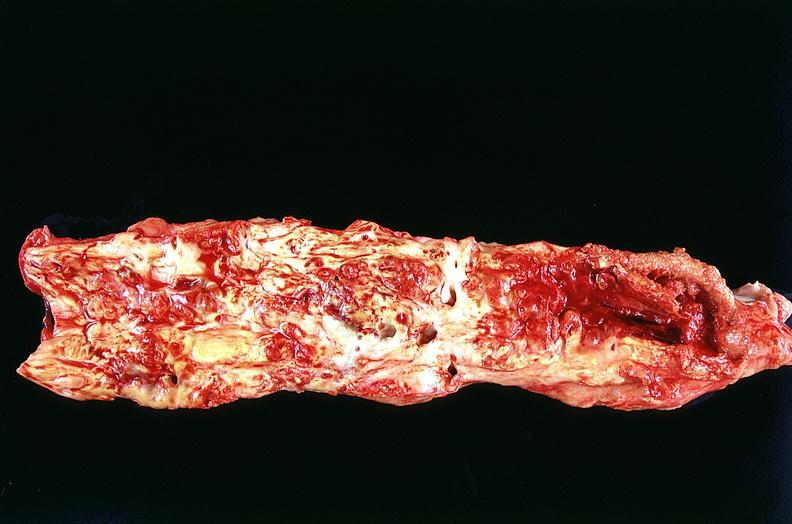where is this?
Answer the question using a single word or phrase. Vasculature 